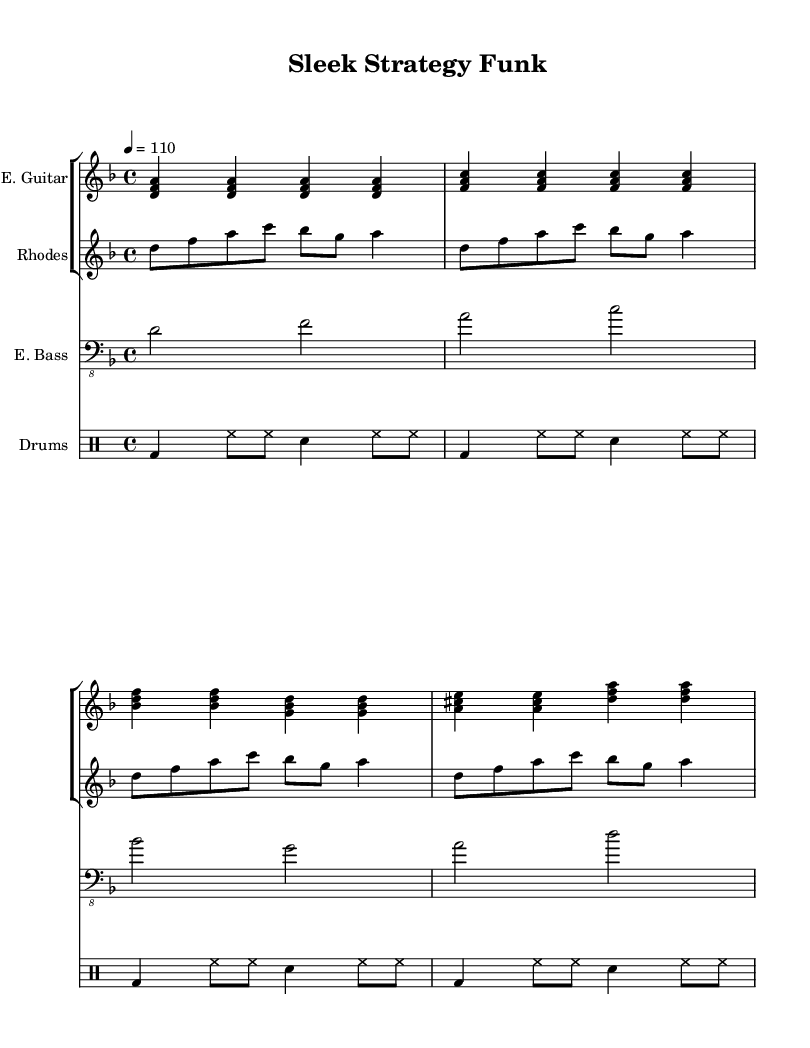What is the key signature of this music? The key signature is D minor, which has one flat (B flat) indicated at the beginning of the staff.
Answer: D minor What is the time signature of the piece? The time signature is 4/4, which is shown at the beginning of the staff with a "4" on top of another "4." This indicates four beats per measure, and the quarter note receives one beat.
Answer: 4/4 What is the tempo marking for this piece? The tempo marking indicates a speed of 110 beats per minute; the marking is found at the top stating "4 = 110." This means that each quarter note is played at this specified speed.
Answer: 110 How many measures are in the electric bass line? To count the measures in the electric bass line, we look at the grouping of notes and see that there are four distinct measures indicated by the bars.
Answer: 4 Which instrument plays chords in this score? The instrument that plays chords is the Electric Guitar, shown by the chord voicings that are played simultaneously in the staff designated for the E. Guitar.
Answer: Electric Guitar What drum pattern is represented as the bass drum? The bass drum is represented by "bd" in the drum patterns, indicating its presence. It consistently plays along with the hi-hat and snare, serving as a foundational rhythm.
Answer: bd How many different instruments are used in this piece? The score includes four different instruments: Electric Guitar, Rhodes Piano, Electric Bass, and Drums, indicated by each separate staff in the score layout.
Answer: 4 